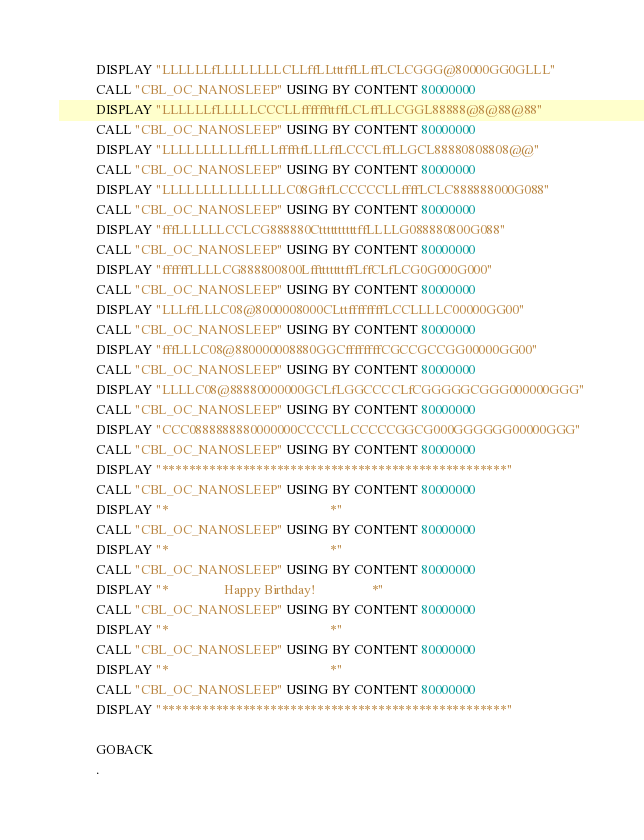Convert code to text. <code><loc_0><loc_0><loc_500><loc_500><_COBOL_>           DISPLAY "LLLLLLfLLLLLLLLCLLffLLtttffLLffLCLCGGG@80000GG0GLLL"
           CALL "CBL_OC_NANOSLEEP" USING BY CONTENT 80000000
           DISPLAY "LLLLLLfLLLLLCCCLLffffffttffLCLffLLCGGL88888@8@88@88"
           CALL "CBL_OC_NANOSLEEP" USING BY CONTENT 80000000
           DISPLAY "LLLLLLLLLLffLLLfffftfLLLffLCCCLffLLGCL88880808808@@"
           CALL "CBL_OC_NANOSLEEP" USING BY CONTENT 80000000
           DISPLAY "LLLLLLLLLLLLLLLC08GftfLCCCCCLLffffLCLC888888000G088"
           CALL "CBL_OC_NANOSLEEP" USING BY CONTENT 80000000
           DISPLAY "fffLLLLLLCCLCG888880CttttttttttffLLLLG088880800G088"
           CALL "CBL_OC_NANOSLEEP" USING BY CONTENT 80000000
           DISPLAY "ffffffLLLLCG888800800LfftttttttffLffCLfLCG0G000G000"
           CALL "CBL_OC_NANOSLEEP" USING BY CONTENT 80000000
           DISPLAY "LLLffLLLC08@8000008000CLttffffffffLCCLLLLC00000GG00"
           CALL "CBL_OC_NANOSLEEP" USING BY CONTENT 80000000
           DISPLAY "fffLLLC08@880000008880GGCffffffffCGCCGCCGG00000GG00"
           CALL "CBL_OC_NANOSLEEP" USING BY CONTENT 80000000
           DISPLAY "LLLLC08@88880000000GCLfLGGCCCCLfCGGGGGCGGG000000GGG"
           CALL "CBL_OC_NANOSLEEP" USING BY CONTENT 80000000
           DISPLAY "CCC0888888880000000CCCCLLCCCCCGGCG000GGGGGG00000GGG"
           CALL "CBL_OC_NANOSLEEP" USING BY CONTENT 80000000
           DISPLAY "***************************************************"
           CALL "CBL_OC_NANOSLEEP" USING BY CONTENT 80000000
           DISPLAY "*                                                 *"
           CALL "CBL_OC_NANOSLEEP" USING BY CONTENT 80000000
           DISPLAY "*                                                 *"
           CALL "CBL_OC_NANOSLEEP" USING BY CONTENT 80000000
           DISPLAY "*                 Happy Birthday!                 *"
           CALL "CBL_OC_NANOSLEEP" USING BY CONTENT 80000000
           DISPLAY "*                                                 *"
           CALL "CBL_OC_NANOSLEEP" USING BY CONTENT 80000000
           DISPLAY "*                                                 *"
           CALL "CBL_OC_NANOSLEEP" USING BY CONTENT 80000000
           DISPLAY "***************************************************"

           GOBACK
           .

</code> 